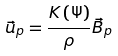Convert formula to latex. <formula><loc_0><loc_0><loc_500><loc_500>\vec { u } _ { p } = \frac { K \left ( \Psi \right ) } { \rho } \vec { B } _ { p }</formula> 